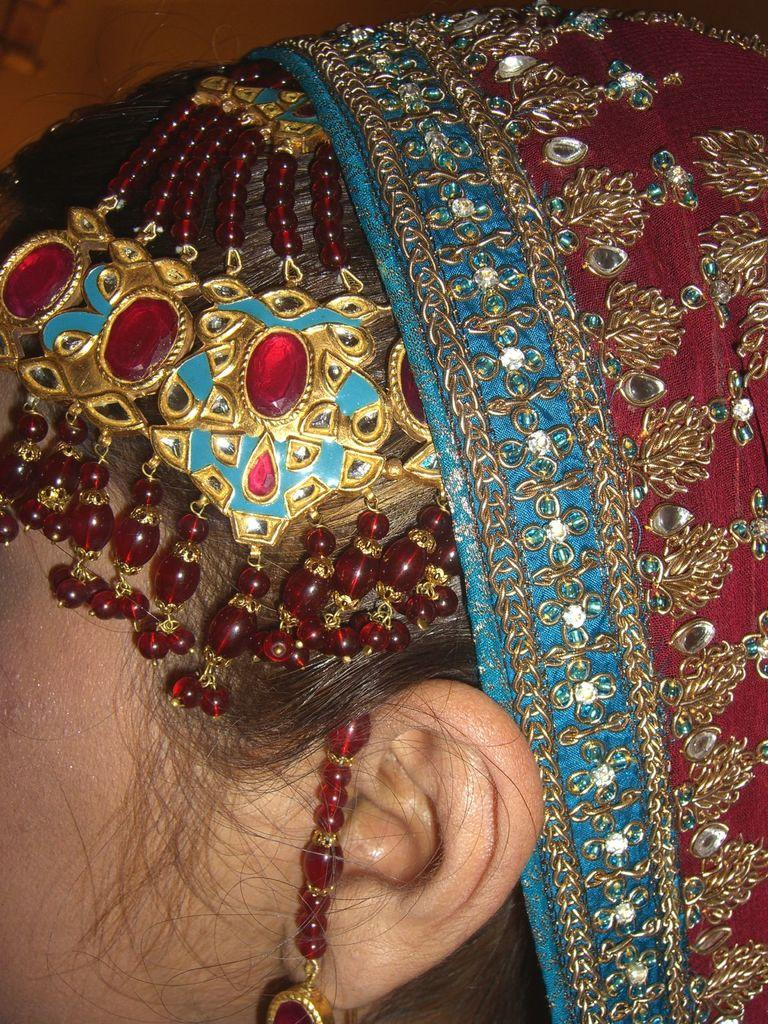What is the main subject of the image? The main subject of the image is the head of a woman. What type of fish can be seen swimming near the woman's head in the image? There is no fish present in the image; it only features the head of a woman. 